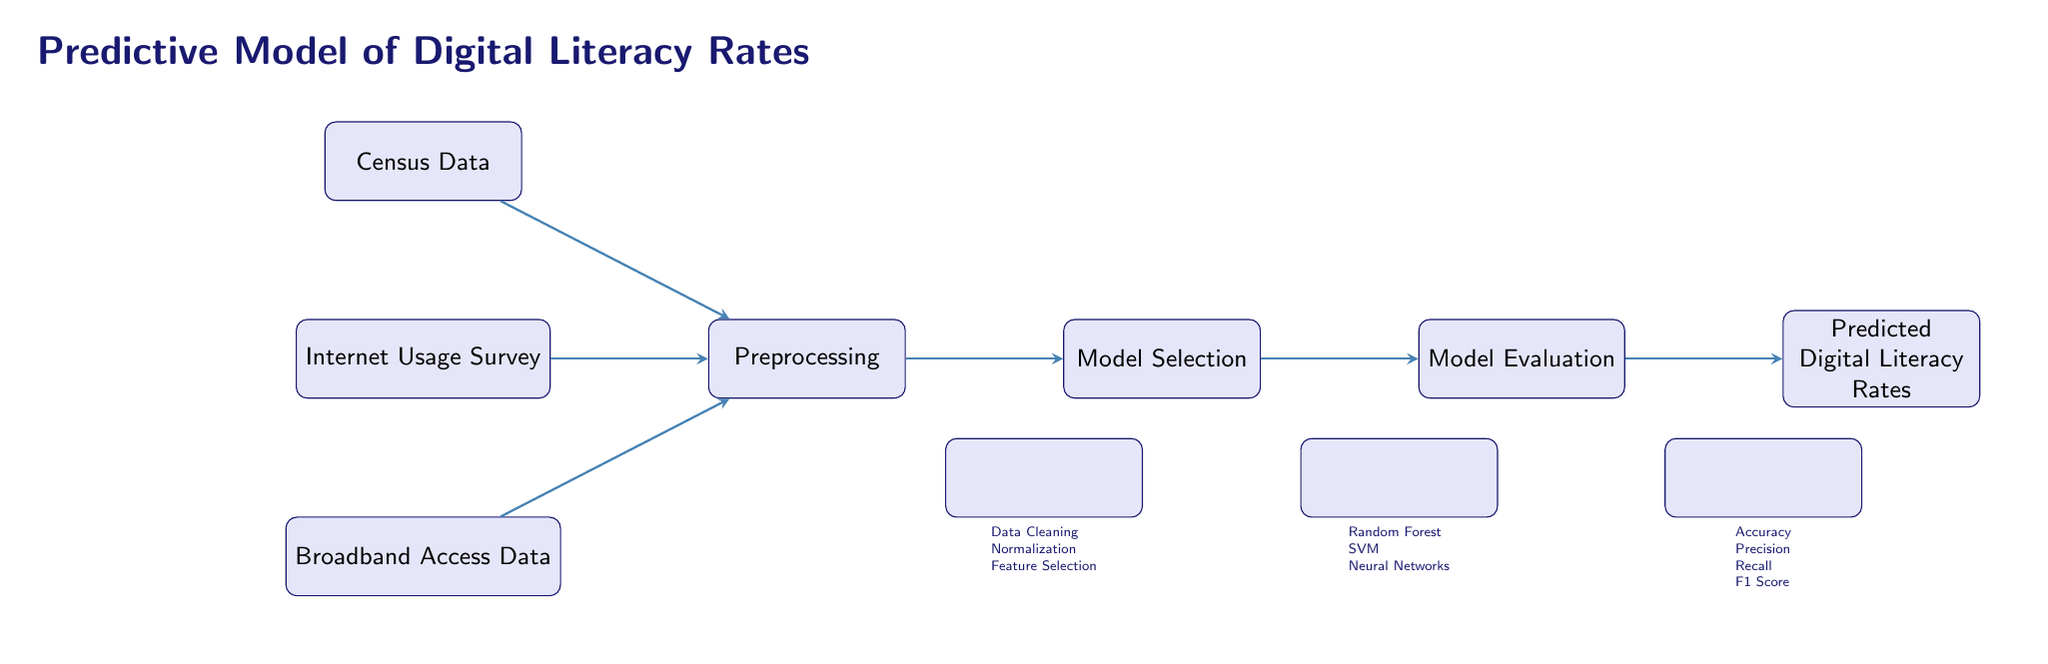What's the first data source in this diagram? The first data source mentioned in the diagram is located at the top and is labeled as "Census Data."
Answer: Census Data How many model options are listed in the model selection step? The model selection step lists three options: Random Forest, SVM, and Neural Networks. Therefore, there are three model options.
Answer: 3 What preprocessing steps are included in the diagram? The preprocessing step includes "Data Cleaning," "Normalization," and "Feature Selection." These are specified under the preprocessing node.
Answer: Data Cleaning, Normalization, Feature Selection What is the final output of the predictive model? The final output after following the flow of the diagram is labeled as "Predicted Digital Literacy Rates." This is clearly indicated at the rightmost end of the diagram.
Answer: Predicted Digital Literacy Rates Which evaluation metrics are used in the model evaluation step? The evaluation metrics listed in the model evaluation step are "Accuracy," "Precision," "Recall," and "F1 Score." These metrics are shown below the model evaluation node.
Answer: Accuracy, Precision, Recall, F1 Score What type of machine learning techniques are suggested for model selection? The diagram suggests using Random Forest, SVM, and Neural Networks as techniques in the model selection step. These techniques directly correspond to the model options provided in the flow.
Answer: Random Forest, SVM, Neural Networks How do the data sources connect to the preprocessing step? All three data sources (Census Data, Internet Usage Survey, and Broadband Access Data) connect directly to the preprocessing step, which shows that they are inputs for data processing.
Answer: Directly connects What are the two phases before the output in the diagram? The two phases before the output are "Model Evaluation" followed by "Model Selection." This indicates the order of operations before arriving at the final output of predicted digital literacy rates.
Answer: Model Evaluation, Model Selection 